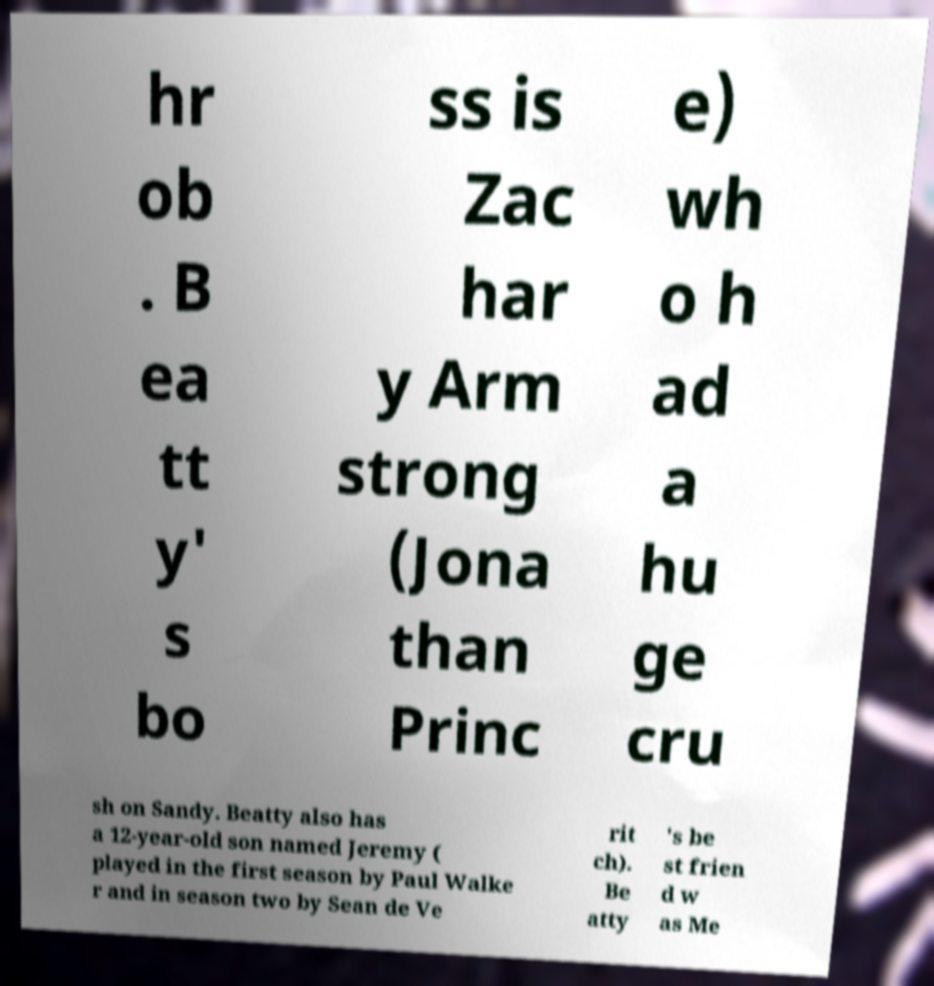There's text embedded in this image that I need extracted. Can you transcribe it verbatim? hr ob . B ea tt y' s bo ss is Zac har y Arm strong (Jona than Princ e) wh o h ad a hu ge cru sh on Sandy. Beatty also has a 12-year-old son named Jeremy ( played in the first season by Paul Walke r and in season two by Sean de Ve rit ch). Be atty 's be st frien d w as Me 